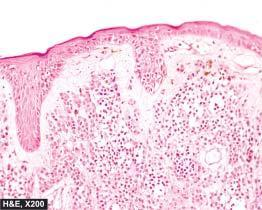what is coarse and irregular?
Answer the question using a single word or phrase. Melanin pigment in naevus cells 